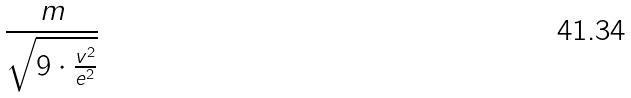<formula> <loc_0><loc_0><loc_500><loc_500>\frac { m } { \sqrt { 9 \cdot \frac { v ^ { 2 } } { e ^ { 2 } } } }</formula> 